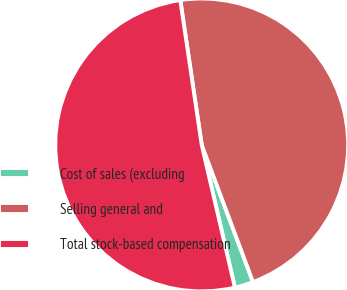<chart> <loc_0><loc_0><loc_500><loc_500><pie_chart><fcel>Cost of sales (excluding<fcel>Selling general and<fcel>Total stock-based compensation<nl><fcel>2.06%<fcel>46.64%<fcel>51.3%<nl></chart> 